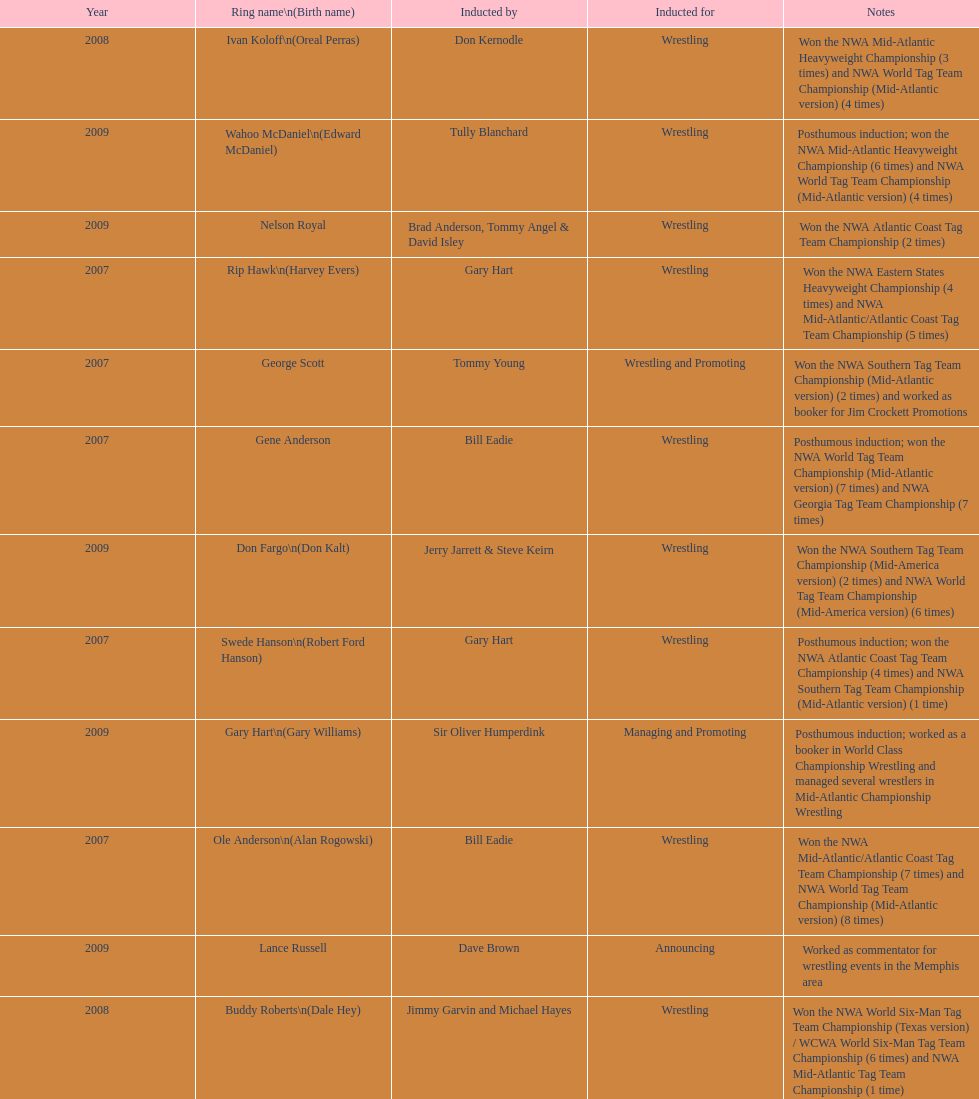What number of members were inducted before 2009? 14. 